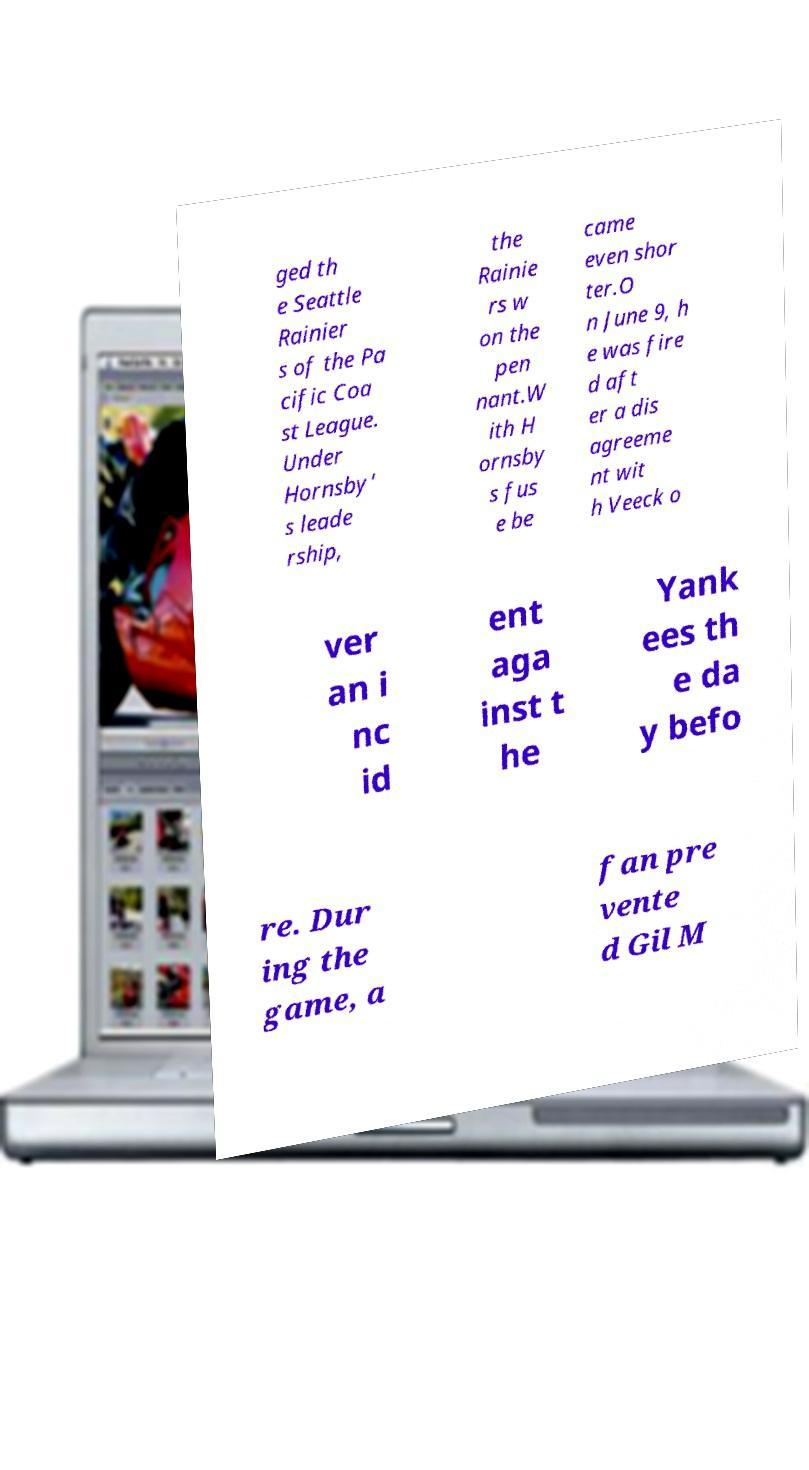Please identify and transcribe the text found in this image. ged th e Seattle Rainier s of the Pa cific Coa st League. Under Hornsby' s leade rship, the Rainie rs w on the pen nant.W ith H ornsby s fus e be came even shor ter.O n June 9, h e was fire d aft er a dis agreeme nt wit h Veeck o ver an i nc id ent aga inst t he Yank ees th e da y befo re. Dur ing the game, a fan pre vente d Gil M 